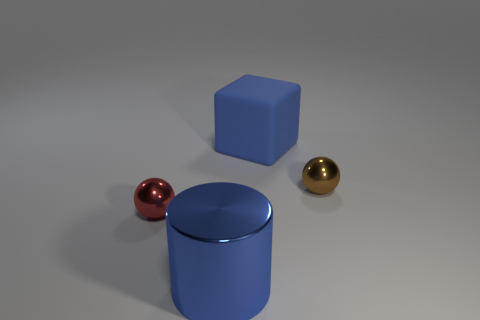Add 3 rubber objects. How many objects exist? 7 Subtract all blocks. How many objects are left? 3 Add 4 blue matte things. How many blue matte things are left? 5 Add 3 cylinders. How many cylinders exist? 4 Subtract 0 red cylinders. How many objects are left? 4 Subtract all yellow cylinders. Subtract all purple spheres. How many cylinders are left? 1 Subtract all large rubber blocks. Subtract all small red metal balls. How many objects are left? 2 